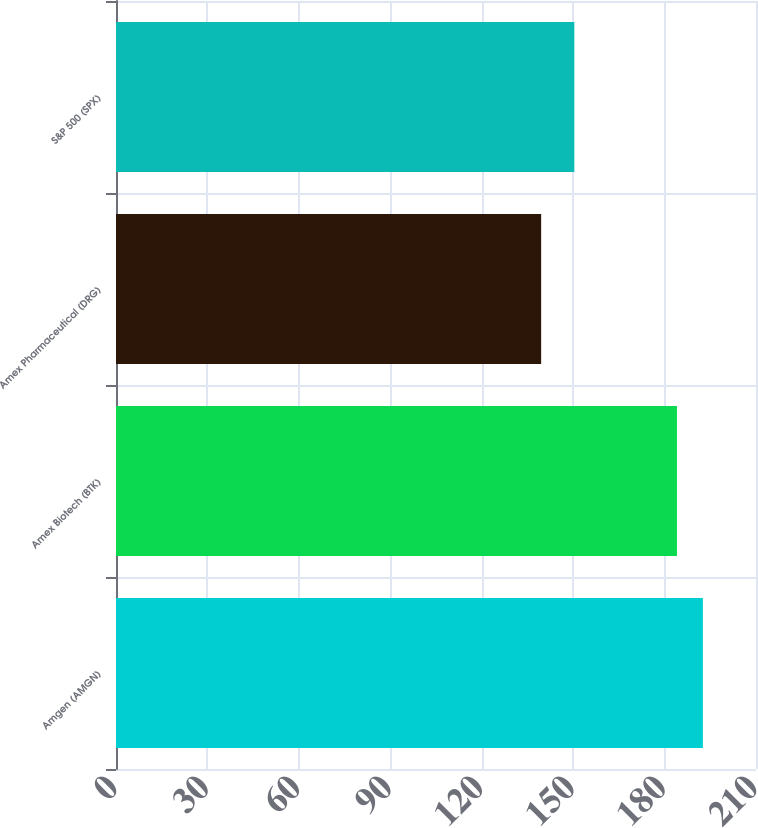<chart> <loc_0><loc_0><loc_500><loc_500><bar_chart><fcel>Amgen (AMGN)<fcel>Amex Biotech (BTK)<fcel>Amex Pharmaceutical (DRG)<fcel>S&P 500 (SPX)<nl><fcel>192.57<fcel>184.07<fcel>139.5<fcel>150.39<nl></chart> 